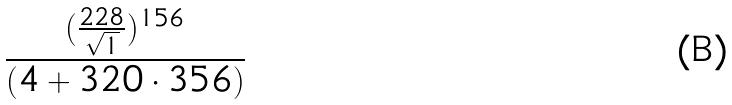<formula> <loc_0><loc_0><loc_500><loc_500>\frac { ( \frac { 2 2 8 } { \sqrt { 1 } } ) ^ { 1 5 6 } } { ( 4 + 3 2 0 \cdot 3 5 6 ) }</formula> 